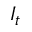Convert formula to latex. <formula><loc_0><loc_0><loc_500><loc_500>I _ { t }</formula> 